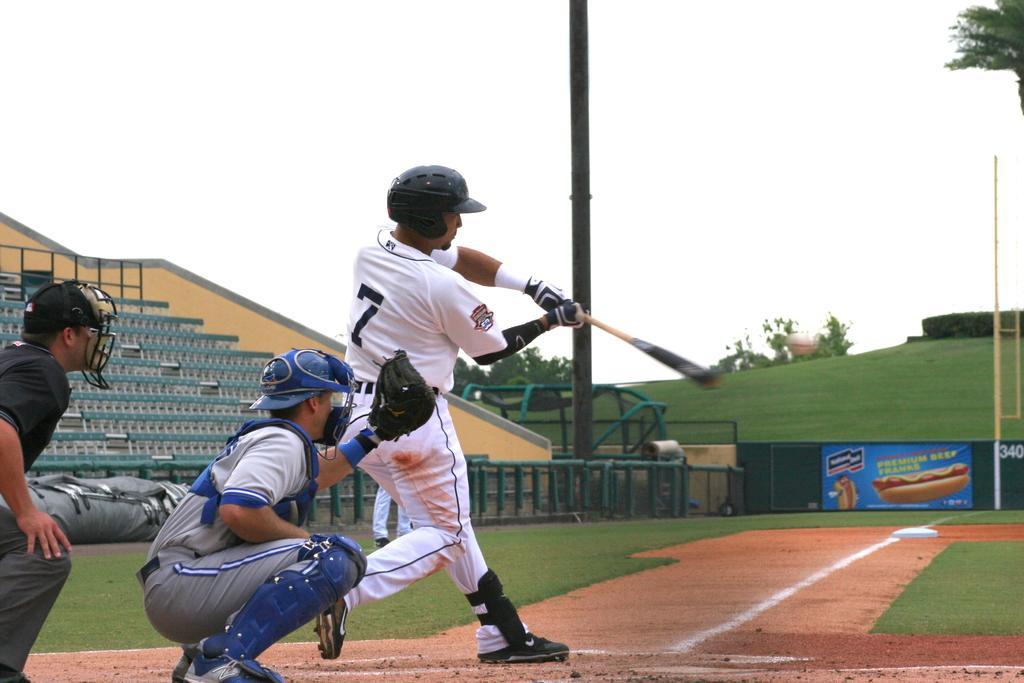Please provide a concise description of this image. This image is taken outdoors. At the bottom of the image there is a ground with grass on it. In the middle of the image a man is playing baseball with a baseball bat. On the left side of the image two men are fielding in the ground. In the background there is a board with a text on it and there is a railing and there are a few benches and there are a few trees. At the top of the image there is a sky. 